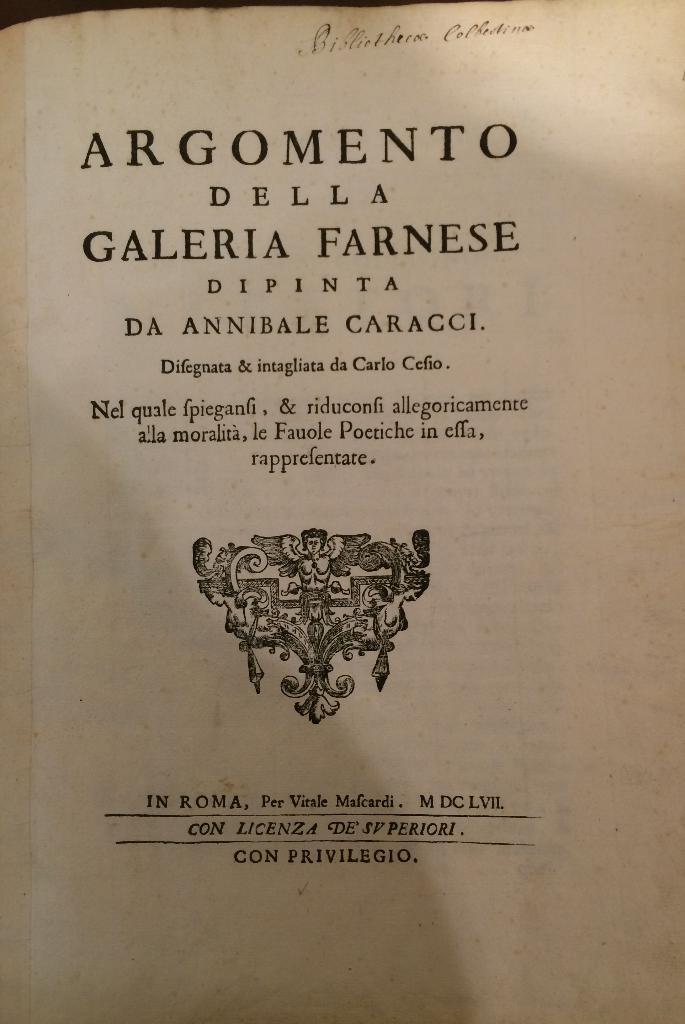What is the name of this book?
Provide a succinct answer. Argomento della galeria farnese. Who wrote the book?
Make the answer very short. Da annibale caracci. 